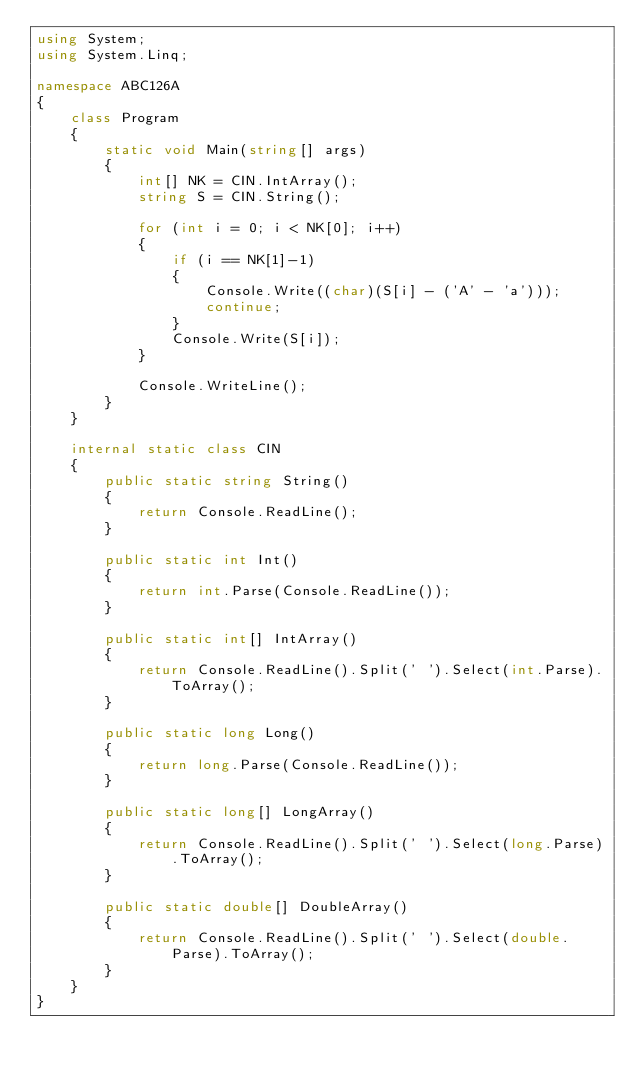<code> <loc_0><loc_0><loc_500><loc_500><_C#_>using System;
using System.Linq;

namespace ABC126A
{
    class Program
    {
        static void Main(string[] args)
        {
            int[] NK = CIN.IntArray();
            string S = CIN.String();

            for (int i = 0; i < NK[0]; i++)
            {
                if (i == NK[1]-1)
                {
                    Console.Write((char)(S[i] - ('A' - 'a')));
                    continue;
                }
                Console.Write(S[i]);
            }

            Console.WriteLine();
        }
    }

    internal static class CIN
    {
        public static string String()
        {
            return Console.ReadLine();
        }

        public static int Int()
        {
            return int.Parse(Console.ReadLine());
        }

        public static int[] IntArray()
        {
            return Console.ReadLine().Split(' ').Select(int.Parse).ToArray();
        }

        public static long Long()
        {
            return long.Parse(Console.ReadLine());
        }

        public static long[] LongArray()
        {
            return Console.ReadLine().Split(' ').Select(long.Parse).ToArray();
        }

        public static double[] DoubleArray()
        {
            return Console.ReadLine().Split(' ').Select(double.Parse).ToArray();
        }
    }
}</code> 